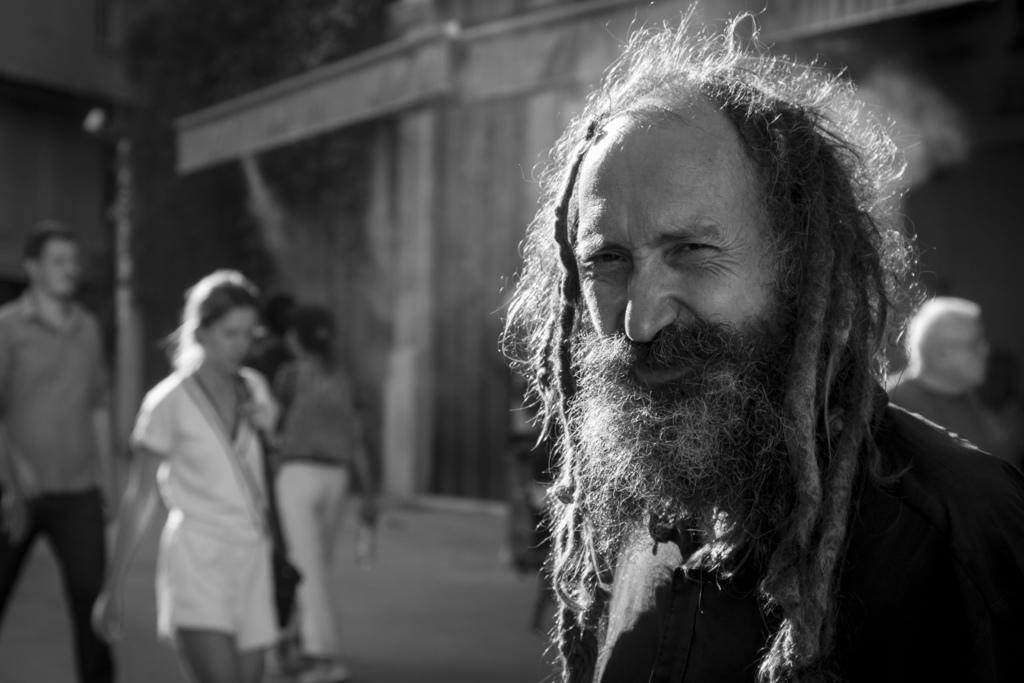What is the color scheme of the image? The image is black and white. Who is the main subject in the image? There is a man in the image. What is the man wearing? The man is wearing clothes. Are there any other people in the image? Yes, there are other people in the image. What are the other people wearing? The other people are also wearing clothes. Can you describe the background of the image? The background of the image is blurred. What type of channel is being watched by the man in the image? There is no indication of a television or any channel being watched in the image. What did the man have for breakfast before the image was taken? There is no information about the man's breakfast in the image or the provided facts. 